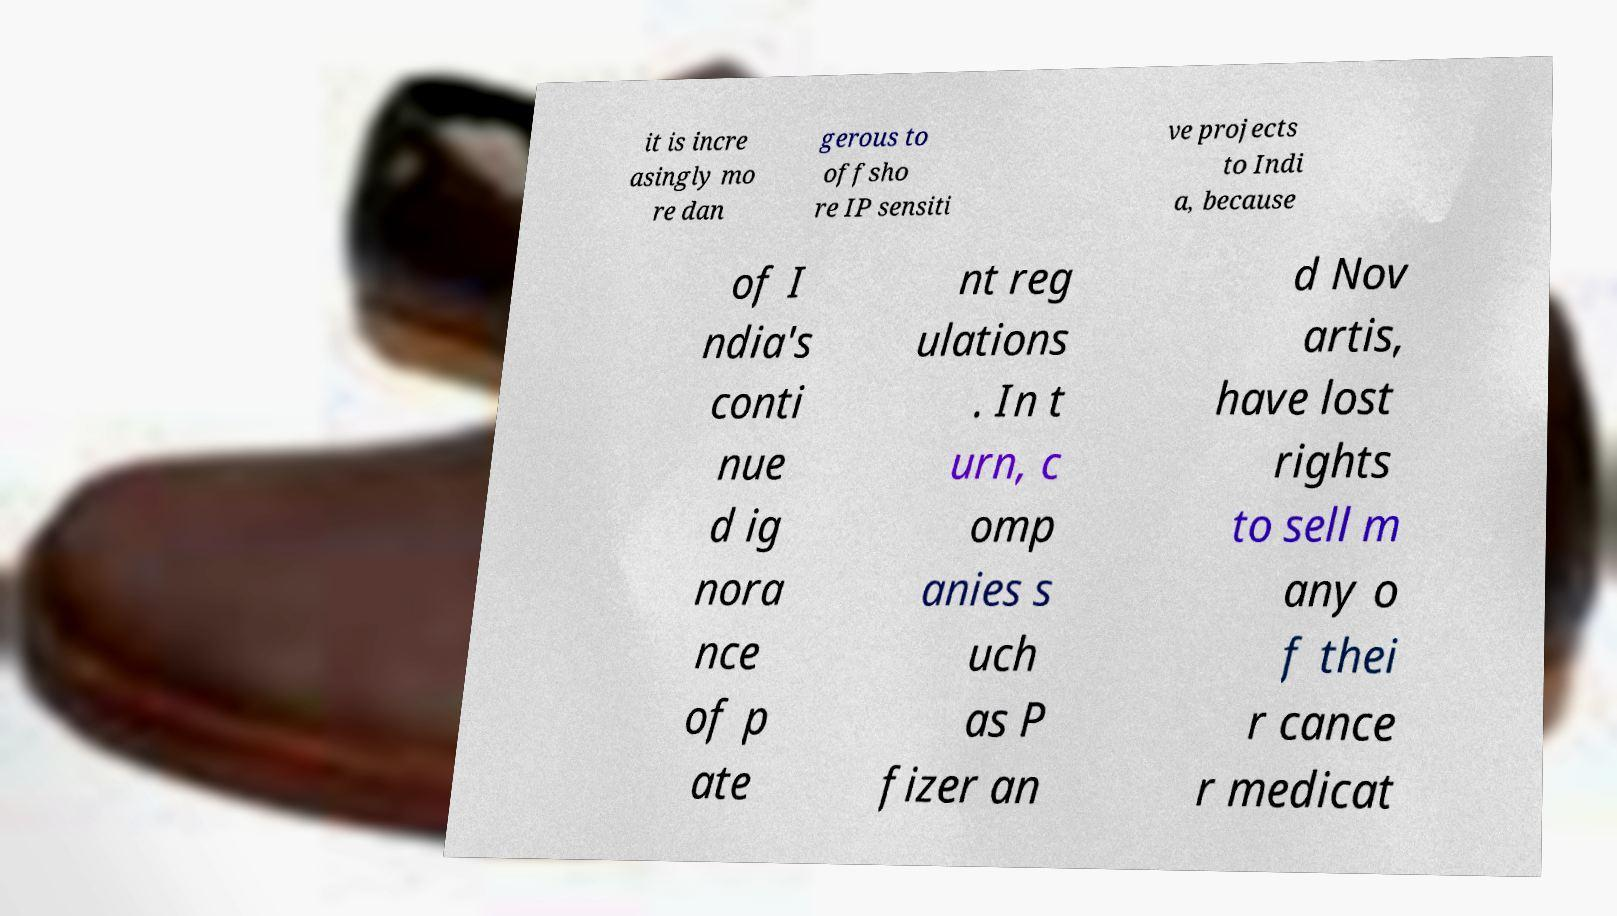I need the written content from this picture converted into text. Can you do that? it is incre asingly mo re dan gerous to offsho re IP sensiti ve projects to Indi a, because of I ndia's conti nue d ig nora nce of p ate nt reg ulations . In t urn, c omp anies s uch as P fizer an d Nov artis, have lost rights to sell m any o f thei r cance r medicat 